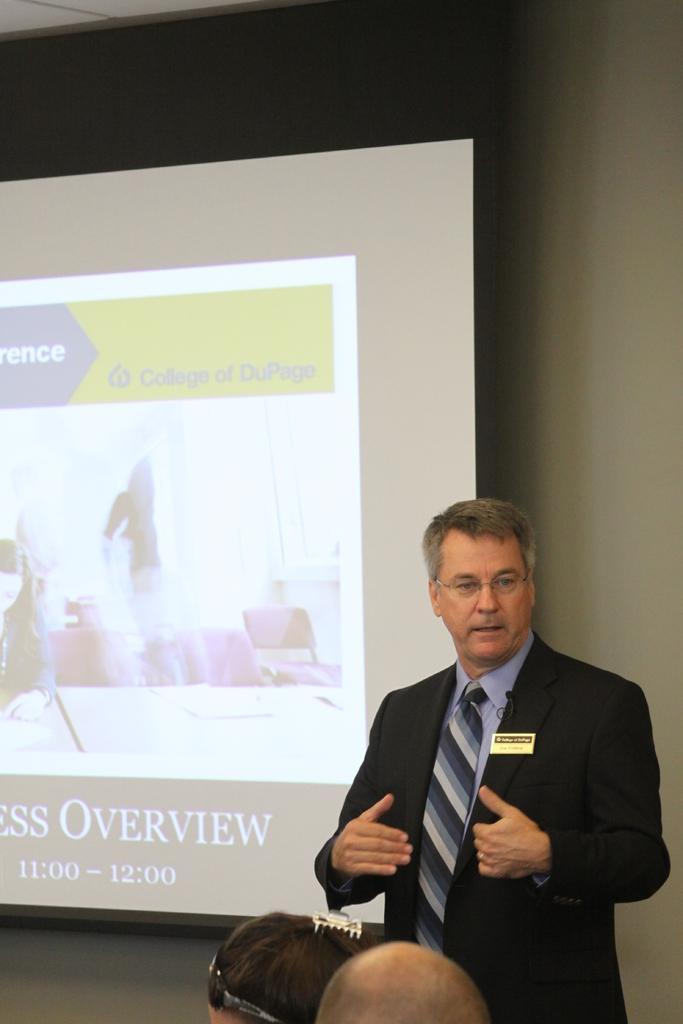Can you describe this image briefly? This image is taken indoors. In the background there is a wall and there is a projector screen on the wall. At the top of the image there is a ceiling. At the bottom of the image there are two people. On the right side of the image a man is standing and talking. 